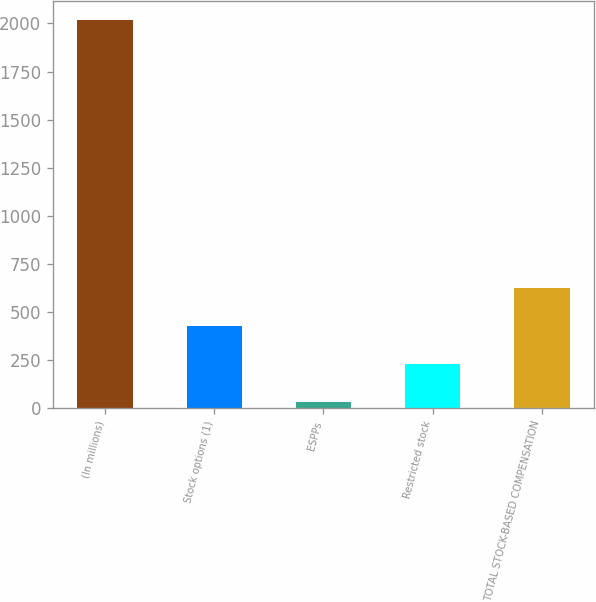Convert chart to OTSL. <chart><loc_0><loc_0><loc_500><loc_500><bar_chart><fcel>(In millions)<fcel>Stock options (1)<fcel>ESPPs<fcel>Restricted stock<fcel>TOTAL STOCK-BASED COMPENSATION<nl><fcel>2016<fcel>428<fcel>31<fcel>229.5<fcel>626.5<nl></chart> 